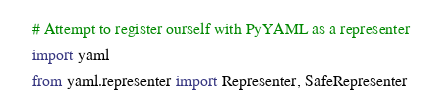Convert code to text. <code><loc_0><loc_0><loc_500><loc_500><_Python_>    # Attempt to register ourself with PyYAML as a representer
    import yaml
    from yaml.representer import Representer, SafeRepresenter
</code> 